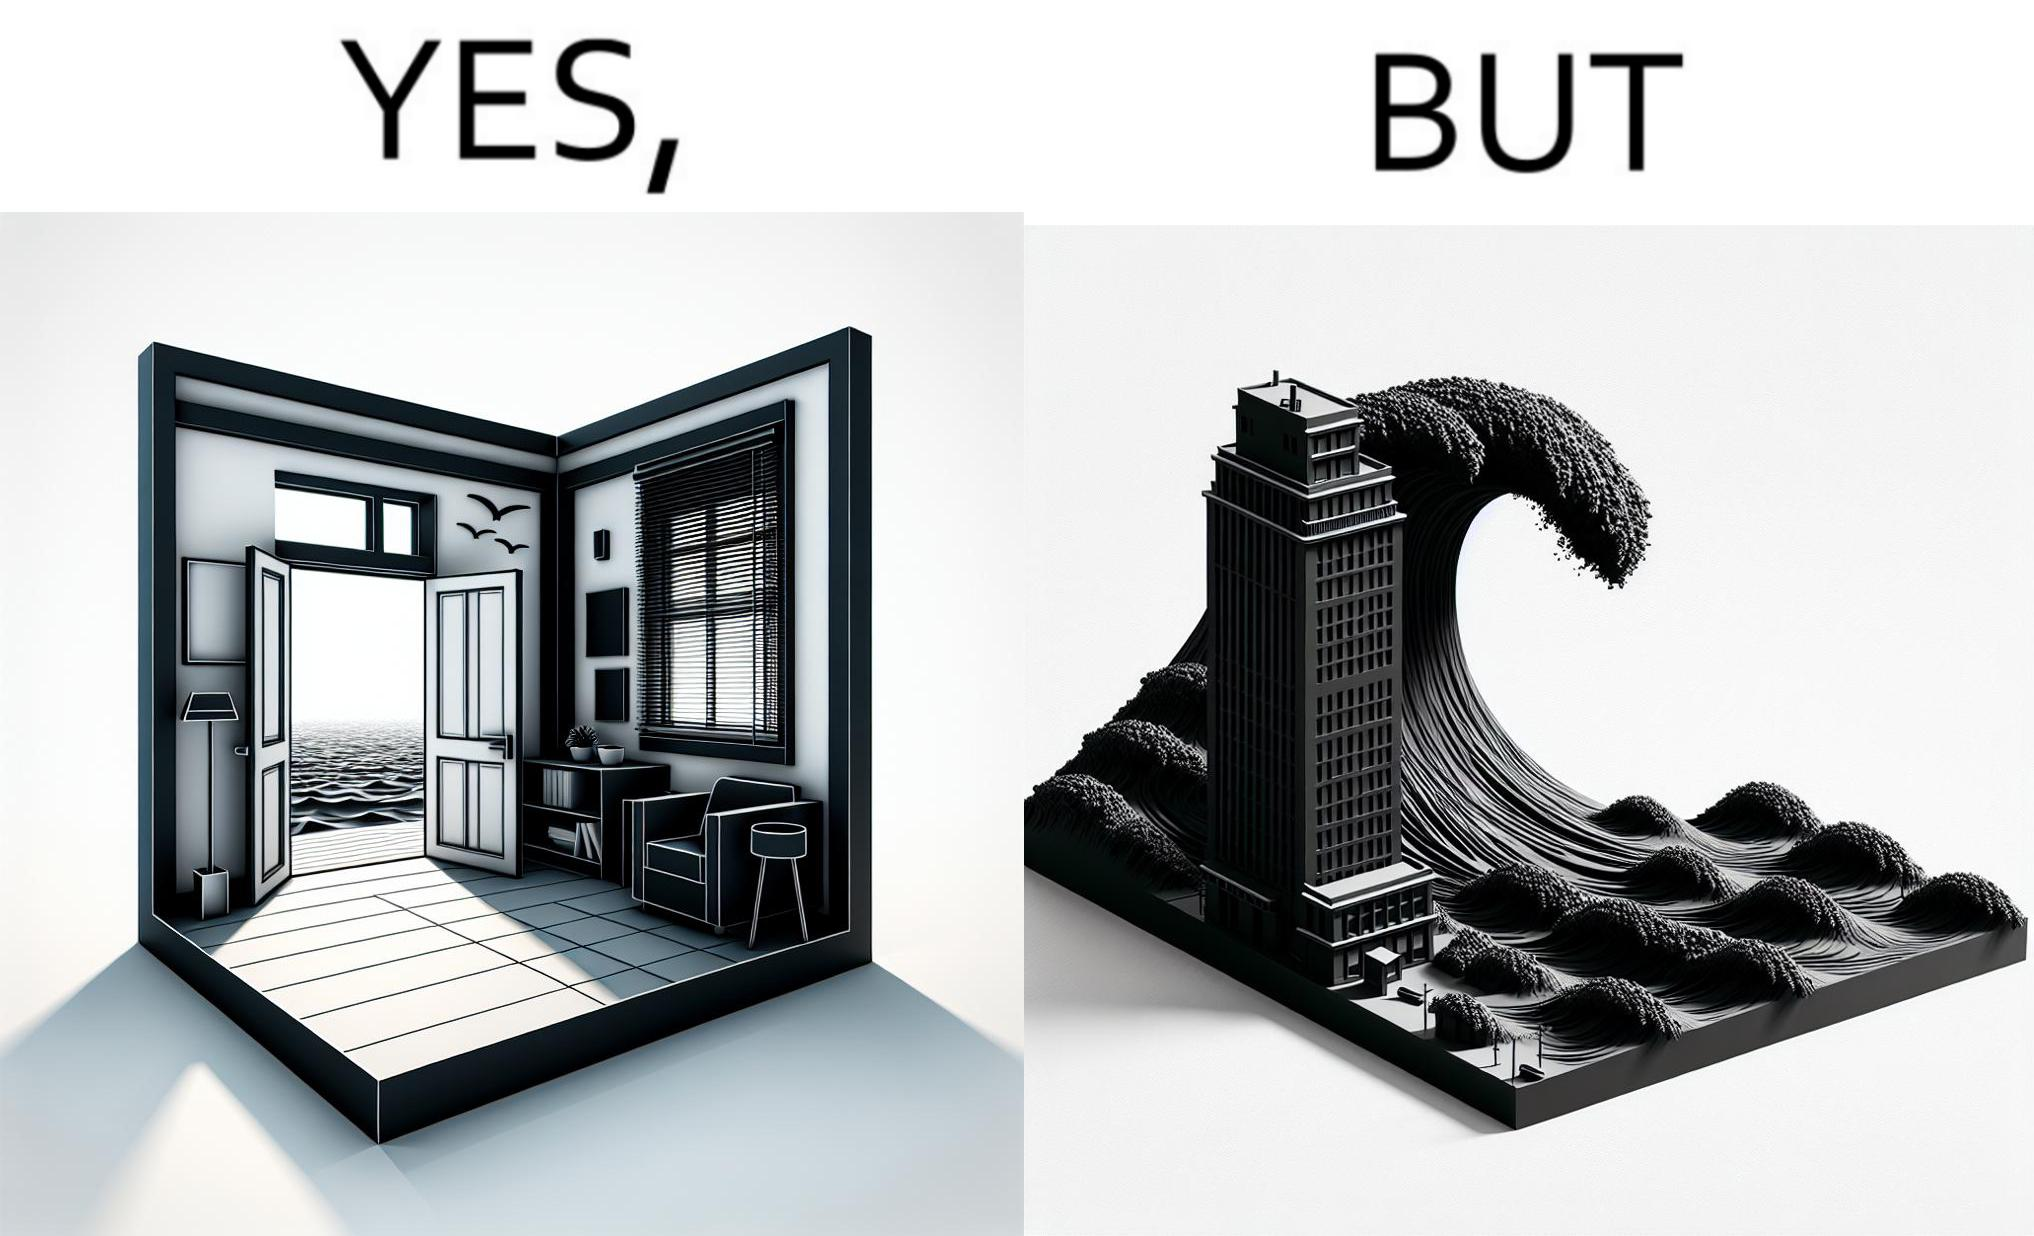Describe the contrast between the left and right parts of this image. In the left part of the image: a room with a sea-facing door In the right part of the image: high waves in the sea twice of the height of the building near the sea 